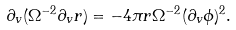Convert formula to latex. <formula><loc_0><loc_0><loc_500><loc_500>\partial _ { v } ( \Omega ^ { - 2 } \partial _ { v } r ) = - 4 \pi r \Omega ^ { - 2 } ( \partial _ { v } \phi ) ^ { 2 } .</formula> 